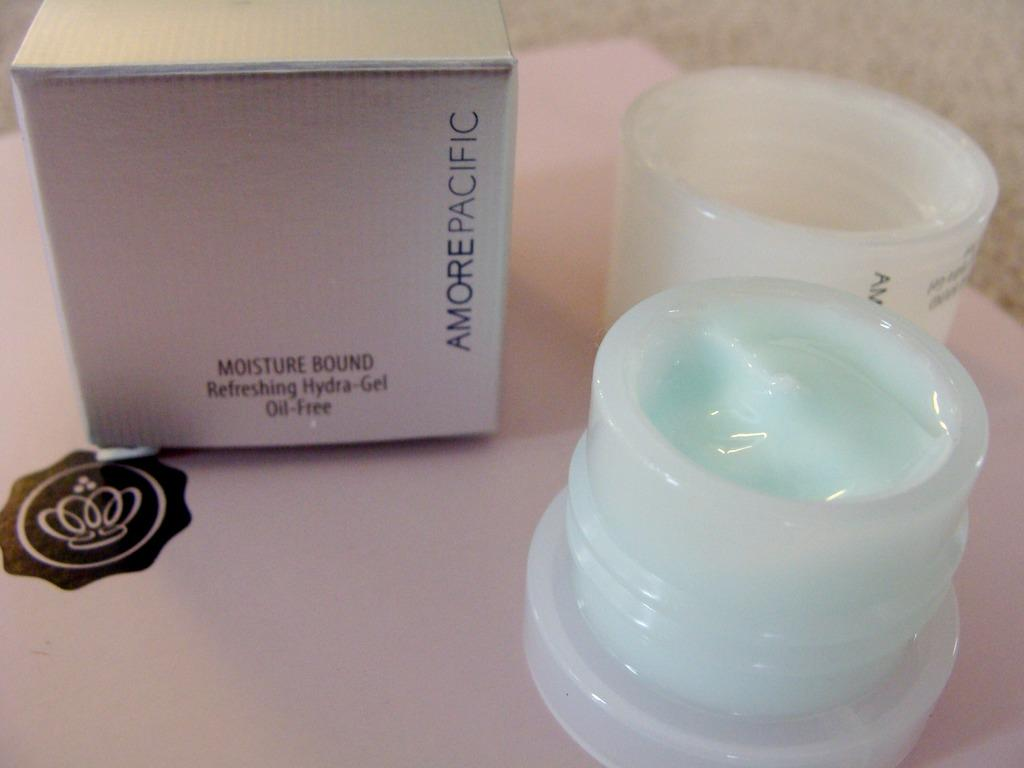<image>
Write a terse but informative summary of the picture. Two jars of cream are next to the product box with the Amore Pacific logo on it. 